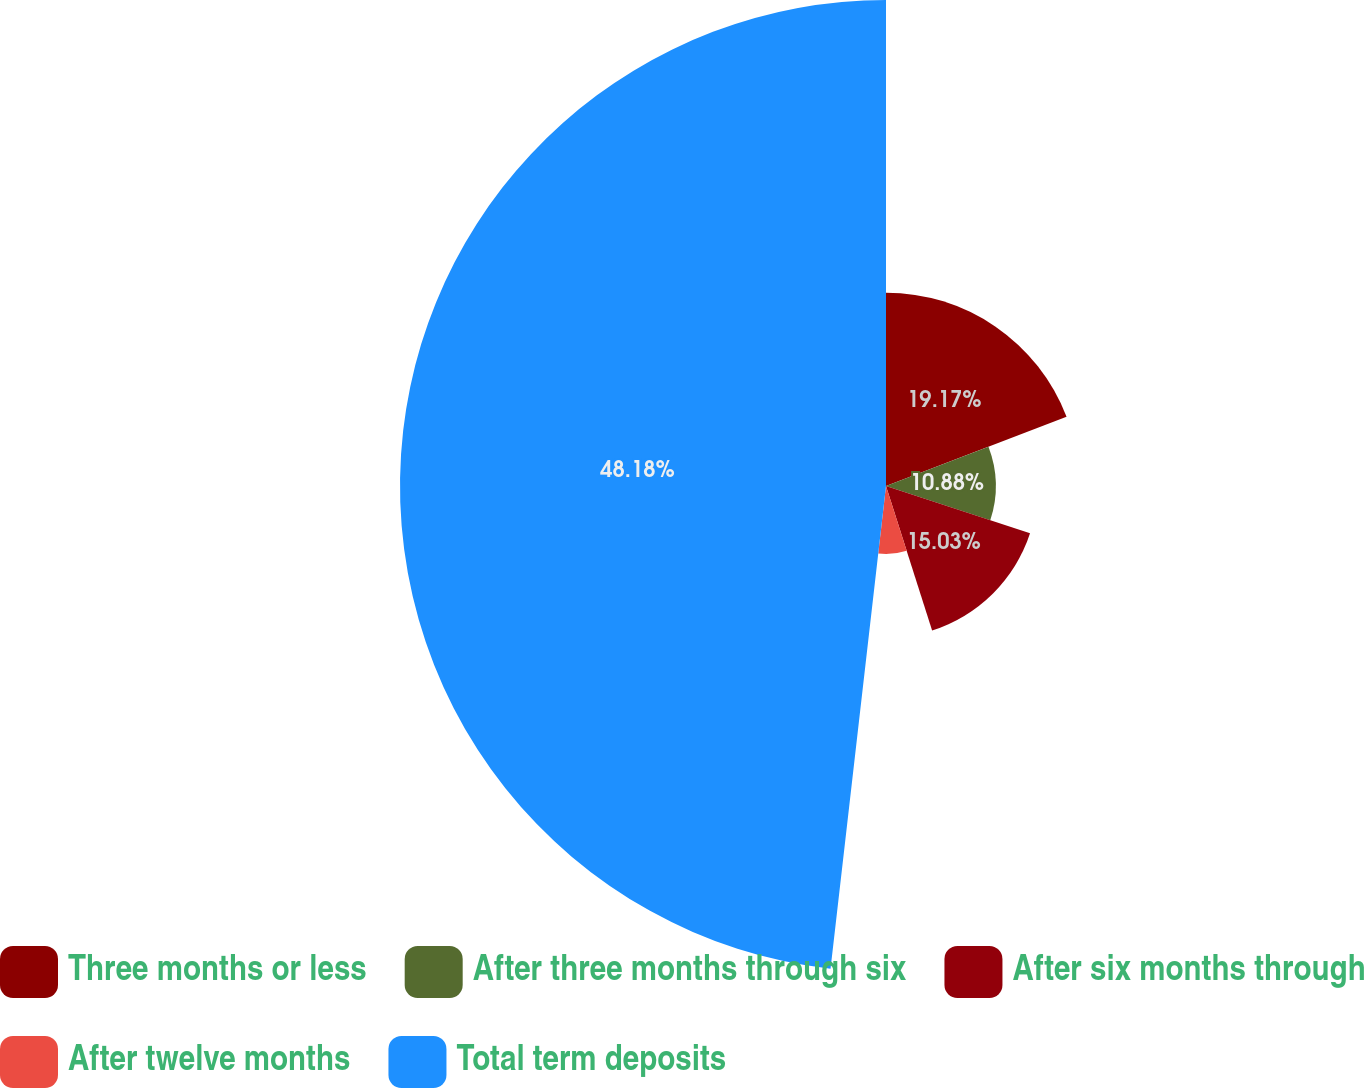Convert chart to OTSL. <chart><loc_0><loc_0><loc_500><loc_500><pie_chart><fcel>Three months or less<fcel>After three months through six<fcel>After six months through<fcel>After twelve months<fcel>Total term deposits<nl><fcel>19.17%<fcel>10.88%<fcel>15.03%<fcel>6.74%<fcel>48.18%<nl></chart> 